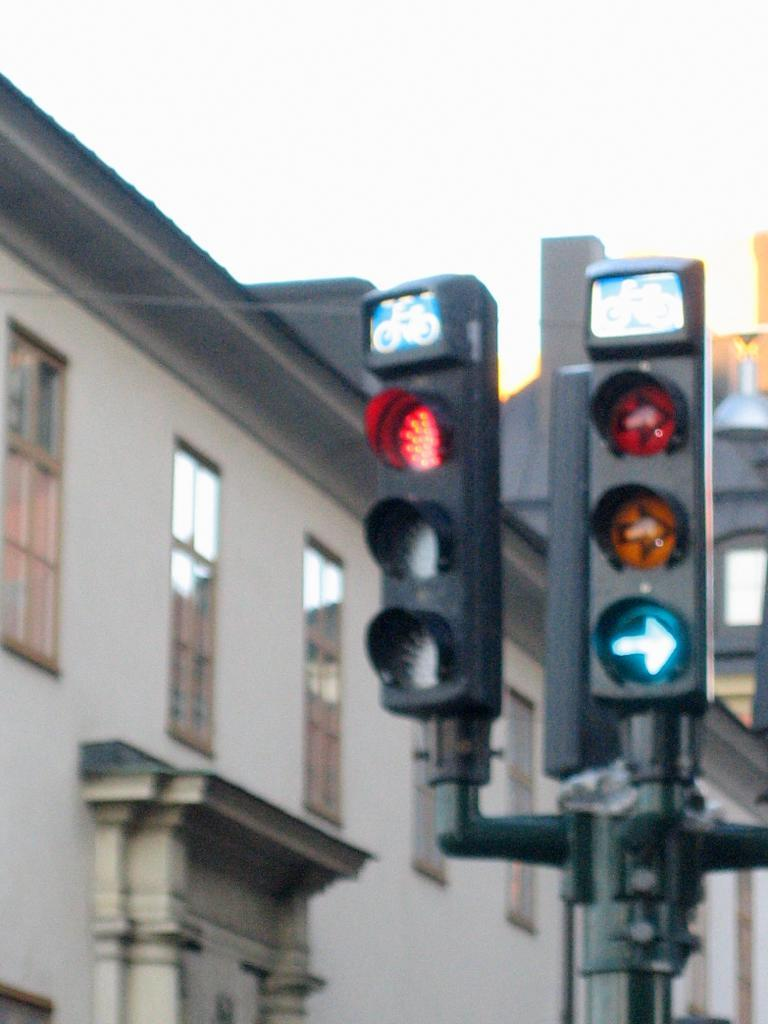What type of structure is located on the left side of the image? There is a building with windows on the left side of the image. What can be seen on the right side of the image? There are traffic signals on a pole on the right side of the image. Where is the crayon located in the image? There is no crayon present in the image. What type of wilderness can be seen in the background of the image? There is no wilderness visible in the image; it features a building and traffic signals. 